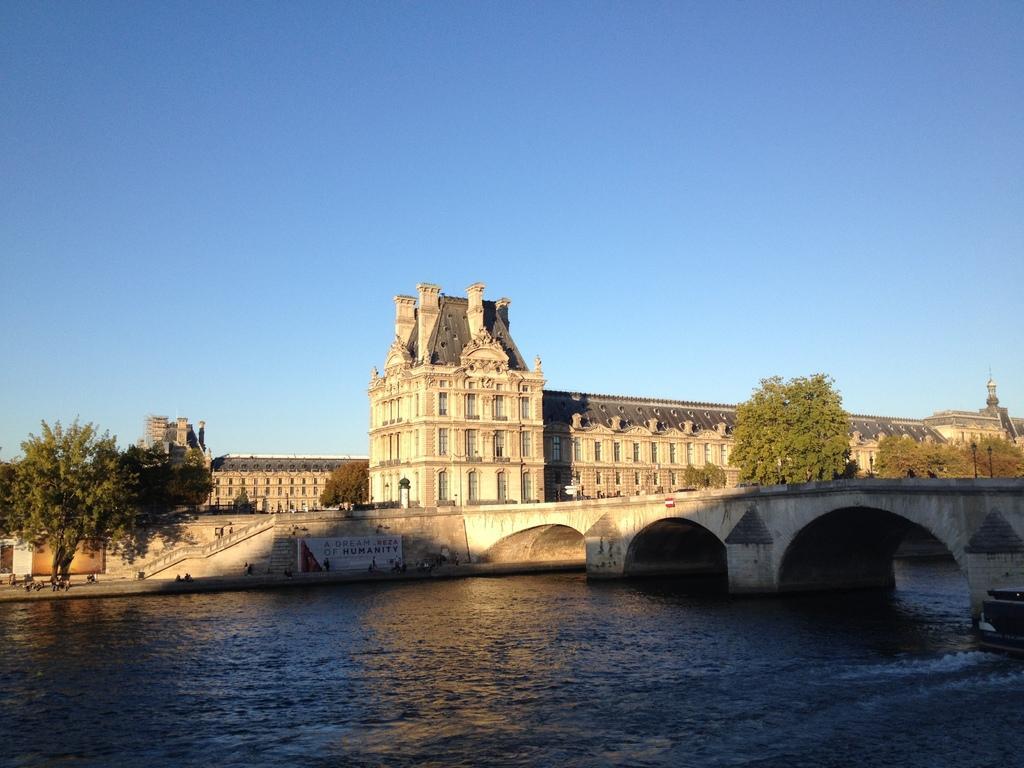Please provide a concise description of this image. In this image we can see buildings, persons on the floor, street poles, street lights, trees, staircase, bridge over the river and sky. 